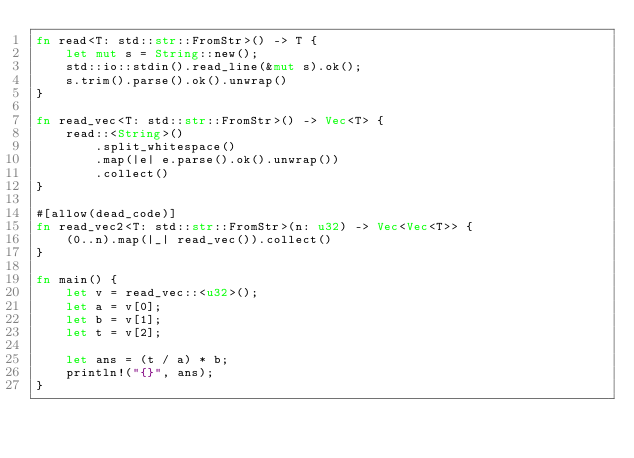Convert code to text. <code><loc_0><loc_0><loc_500><loc_500><_Rust_>fn read<T: std::str::FromStr>() -> T {
    let mut s = String::new();
    std::io::stdin().read_line(&mut s).ok();
    s.trim().parse().ok().unwrap()
}

fn read_vec<T: std::str::FromStr>() -> Vec<T> {
    read::<String>()
        .split_whitespace()
        .map(|e| e.parse().ok().unwrap())
        .collect()
}

#[allow(dead_code)]
fn read_vec2<T: std::str::FromStr>(n: u32) -> Vec<Vec<T>> {
    (0..n).map(|_| read_vec()).collect()
}

fn main() {
    let v = read_vec::<u32>();
    let a = v[0];
    let b = v[1];
    let t = v[2];

    let ans = (t / a) * b;
    println!("{}", ans);
}
</code> 